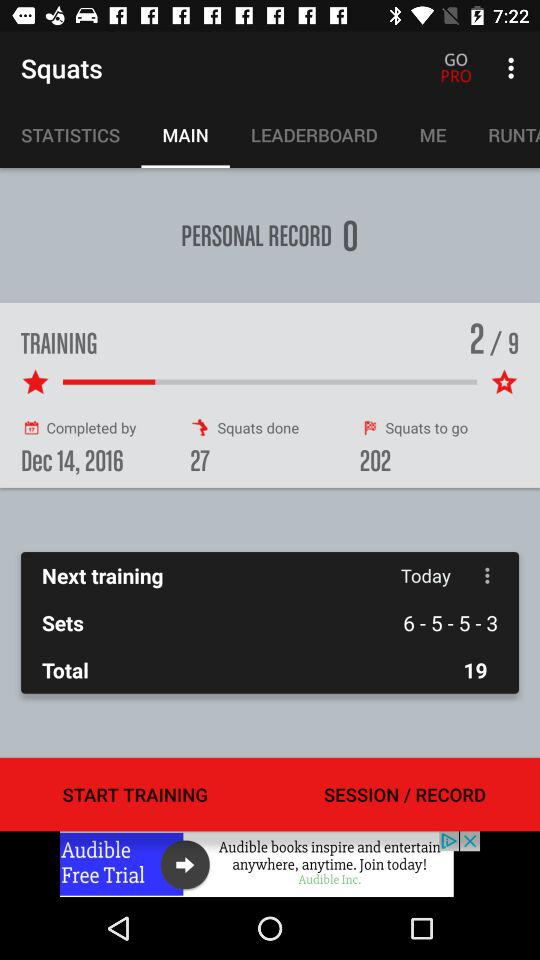When is the next training? The next training is on today. 